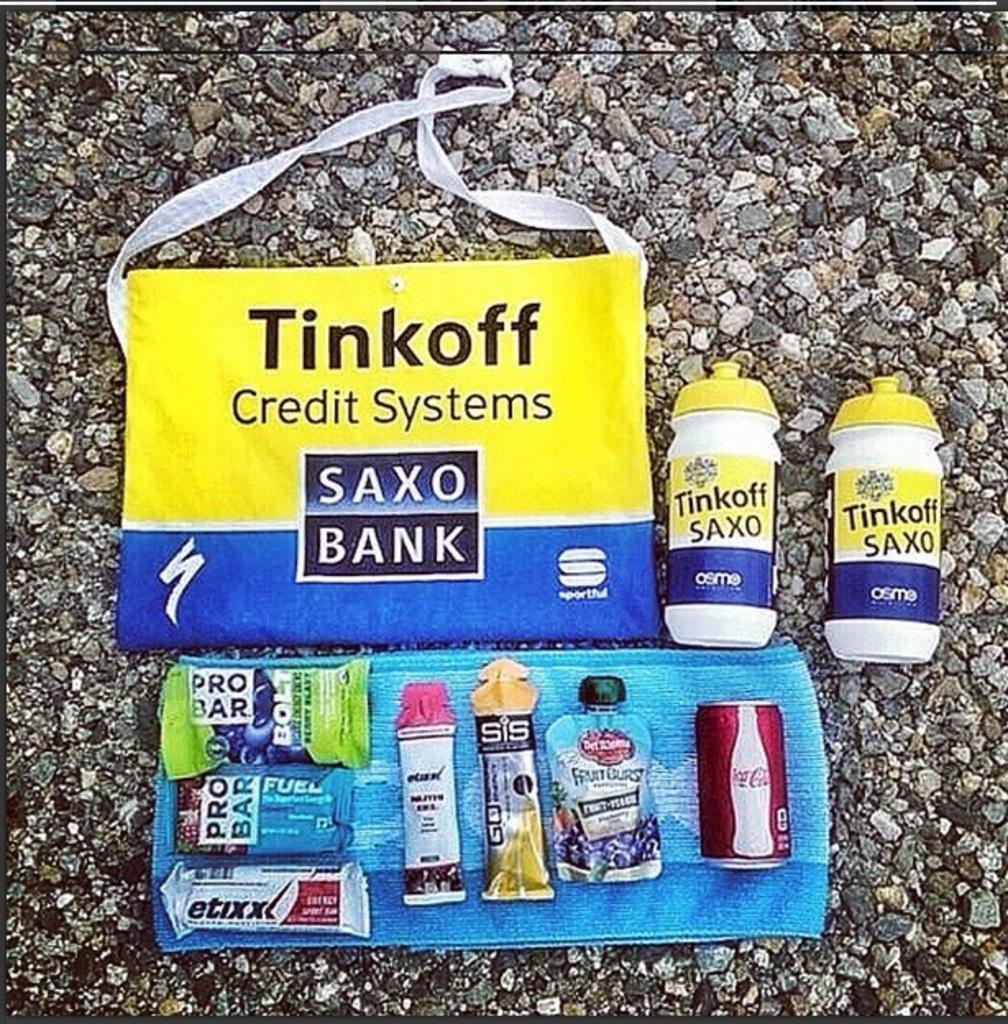Can you describe this image briefly? A bag and two plastic containers are labelled with the name "Tinkoff". There are some protein bars,a coke tin and few eatables are placed on a napkin. 